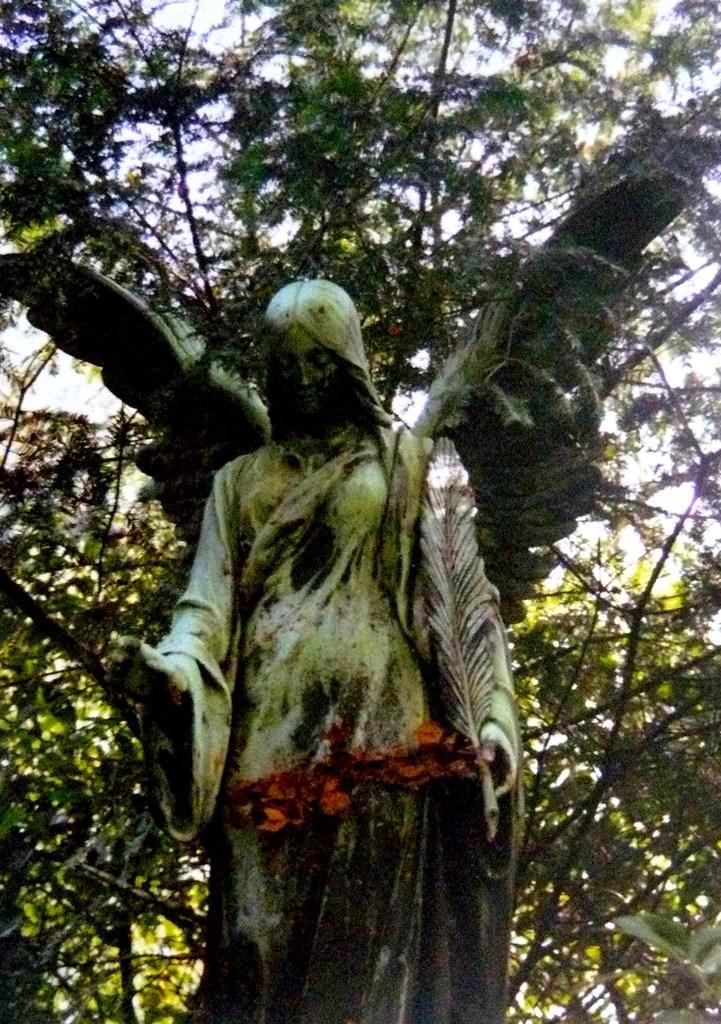Could you give a brief overview of what you see in this image? In the image there is a statue of an angel in front of the tree. 